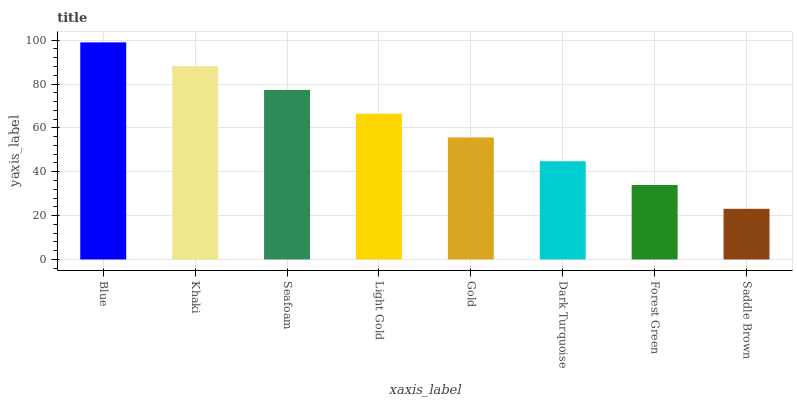Is Saddle Brown the minimum?
Answer yes or no. Yes. Is Blue the maximum?
Answer yes or no. Yes. Is Khaki the minimum?
Answer yes or no. No. Is Khaki the maximum?
Answer yes or no. No. Is Blue greater than Khaki?
Answer yes or no. Yes. Is Khaki less than Blue?
Answer yes or no. Yes. Is Khaki greater than Blue?
Answer yes or no. No. Is Blue less than Khaki?
Answer yes or no. No. Is Light Gold the high median?
Answer yes or no. Yes. Is Gold the low median?
Answer yes or no. Yes. Is Gold the high median?
Answer yes or no. No. Is Khaki the low median?
Answer yes or no. No. 